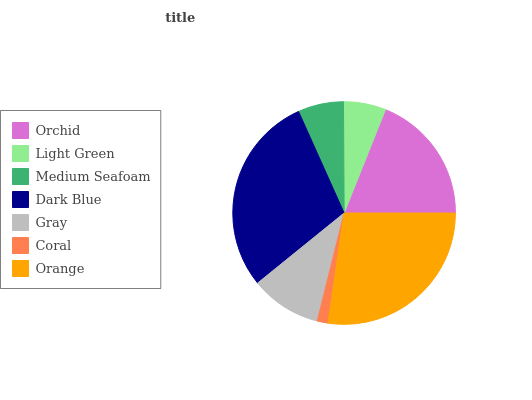Is Coral the minimum?
Answer yes or no. Yes. Is Dark Blue the maximum?
Answer yes or no. Yes. Is Light Green the minimum?
Answer yes or no. No. Is Light Green the maximum?
Answer yes or no. No. Is Orchid greater than Light Green?
Answer yes or no. Yes. Is Light Green less than Orchid?
Answer yes or no. Yes. Is Light Green greater than Orchid?
Answer yes or no. No. Is Orchid less than Light Green?
Answer yes or no. No. Is Gray the high median?
Answer yes or no. Yes. Is Gray the low median?
Answer yes or no. Yes. Is Medium Seafoam the high median?
Answer yes or no. No. Is Orange the low median?
Answer yes or no. No. 